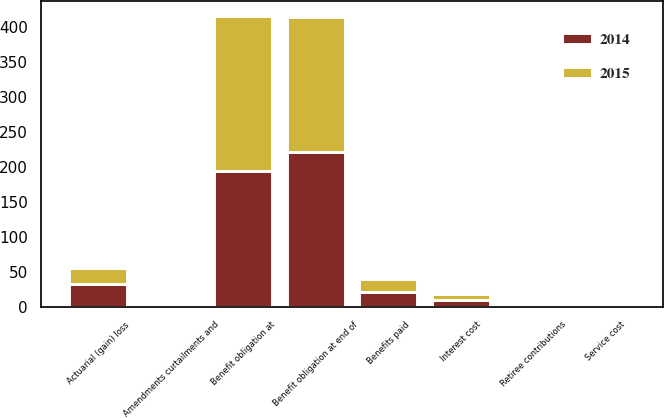Convert chart. <chart><loc_0><loc_0><loc_500><loc_500><stacked_bar_chart><ecel><fcel>Benefit obligation at<fcel>Service cost<fcel>Interest cost<fcel>Amendments curtailments and<fcel>Actuarial (gain) loss<fcel>Retiree contributions<fcel>Benefits paid<fcel>Benefit obligation at end of<nl><fcel>2015<fcel>221.4<fcel>1.1<fcel>8.4<fcel>3.6<fcel>22.7<fcel>3.6<fcel>19.8<fcel>193.4<nl><fcel>2014<fcel>194.8<fcel>1.1<fcel>10.3<fcel>1<fcel>33.2<fcel>3.7<fcel>20.7<fcel>221.4<nl></chart> 